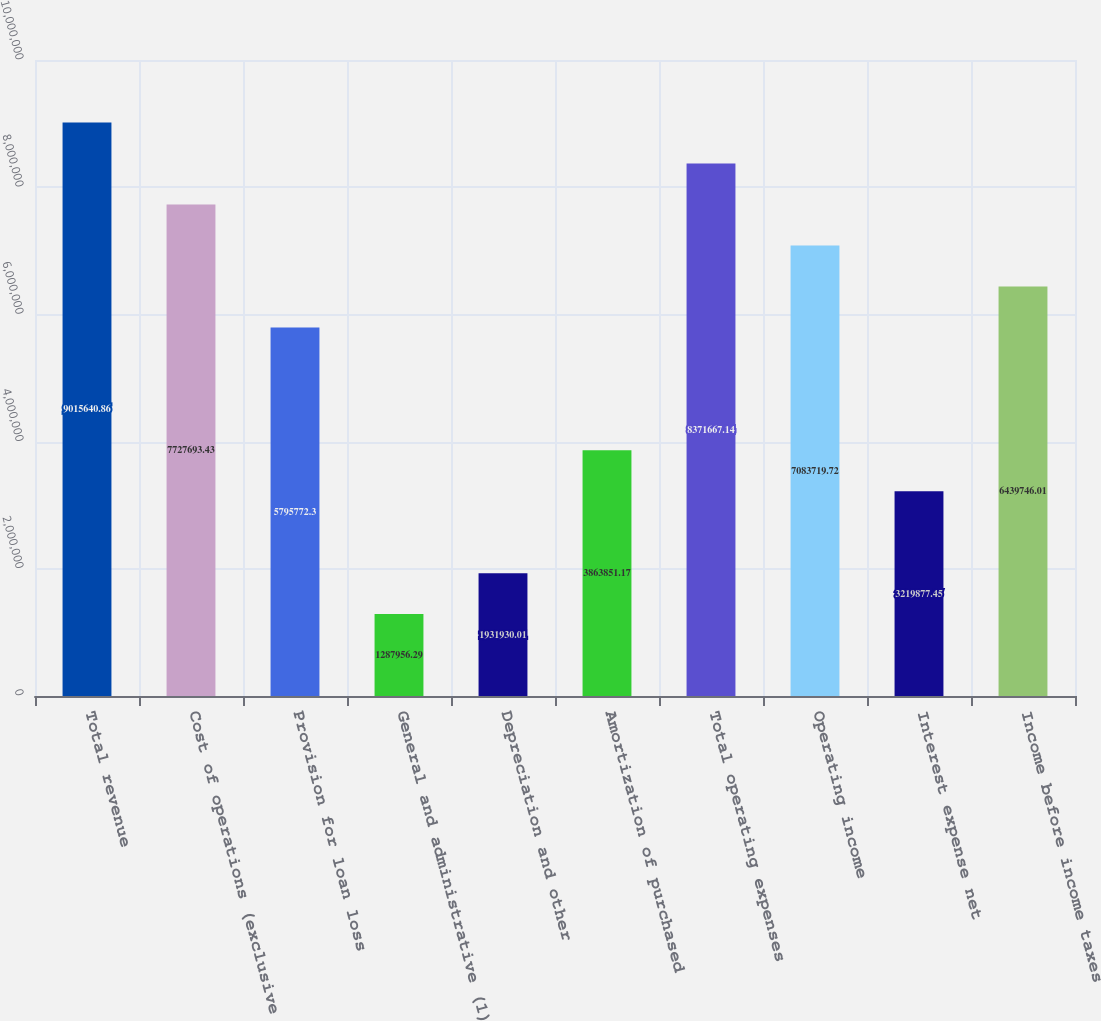<chart> <loc_0><loc_0><loc_500><loc_500><bar_chart><fcel>Total revenue<fcel>Cost of operations (exclusive<fcel>Provision for loan loss<fcel>General and administrative (1)<fcel>Depreciation and other<fcel>Amortization of purchased<fcel>Total operating expenses<fcel>Operating income<fcel>Interest expense net<fcel>Income before income taxes<nl><fcel>9.01564e+06<fcel>7.72769e+06<fcel>5.79577e+06<fcel>1.28796e+06<fcel>1.93193e+06<fcel>3.86385e+06<fcel>8.37167e+06<fcel>7.08372e+06<fcel>3.21988e+06<fcel>6.43975e+06<nl></chart> 